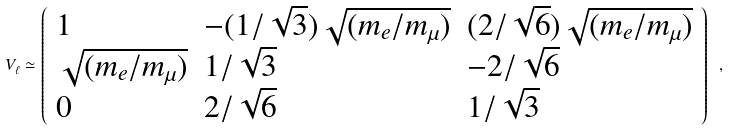Convert formula to latex. <formula><loc_0><loc_0><loc_500><loc_500>V _ { \ell } \simeq \left ( \begin{array} { l l l } { 1 } & { { - ( 1 / \sqrt { 3 } ) \sqrt { ( m _ { e } / m _ { \mu } ) } } } & { { ( 2 / \sqrt { 6 } ) \sqrt { ( m _ { e } / m _ { \mu } ) } } } \\ { { \sqrt { ( m _ { e } / m _ { \mu } ) } } } & { 1 / \sqrt { 3 } } & { - 2 / \sqrt { 6 } } \\ { 0 } & { 2 / \sqrt { 6 } } & { 1 / \sqrt { 3 } } \end{array} \right ) \ ,</formula> 